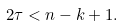Convert formula to latex. <formula><loc_0><loc_0><loc_500><loc_500>2 \tau < n - k + 1 .</formula> 